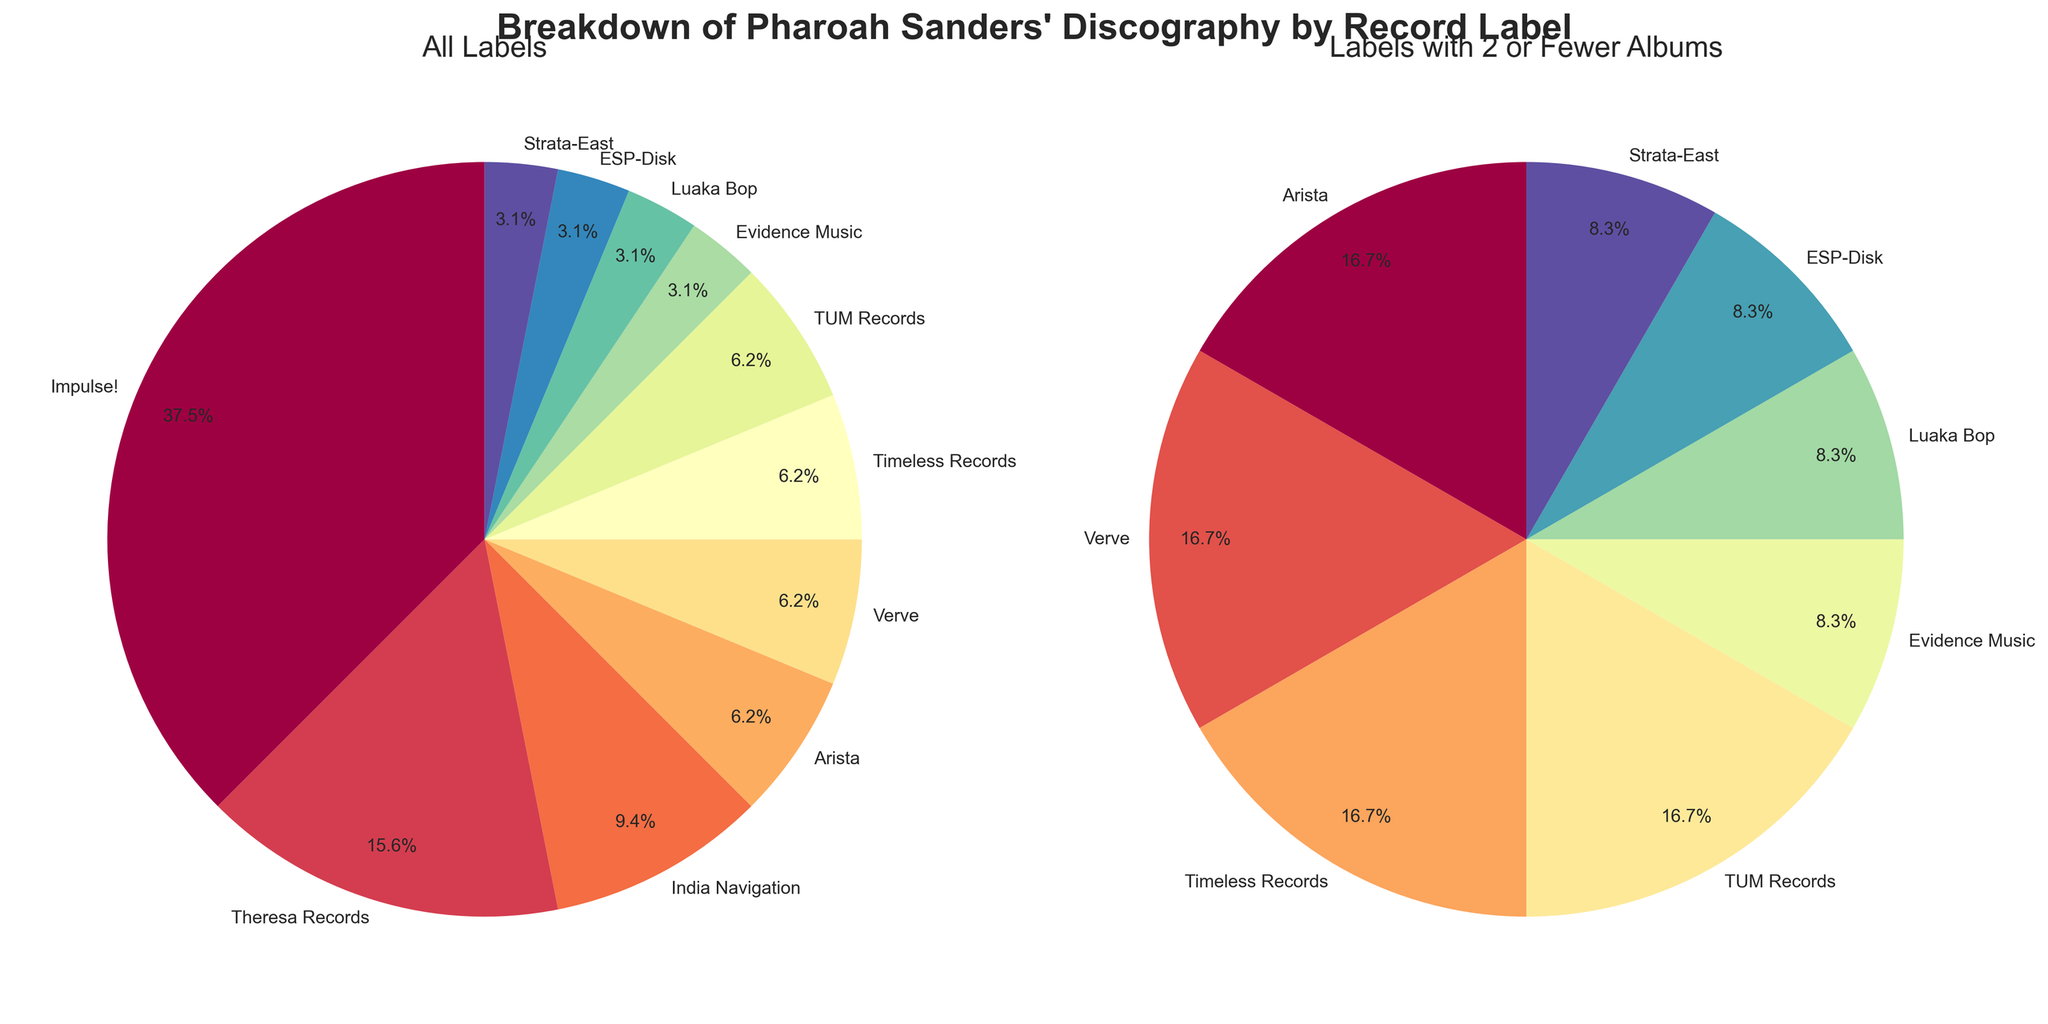What is the title of the figure? The title of the figure is displayed prominently at the top and reads "Breakdown of Pharoah Sanders' Discography by Record Label."
Answer: Breakdown of Pharoah Sanders' Discography by Record Label Which record label has the highest number of albums by Pharoah Sanders? The largest section in the main pie chart corresponds to the label with the highest number of albums. Impulse! has the largest section with 12 albums.
Answer: Impulse! How many record labels feature 2 or fewer albums by Pharoah Sanders? In the second pie chart titled "Labels with 2 or Fewer Albums," we can count the number of segments. There are 7 labels (Theresa Records, Verve, Timeless Records, TUM Records, Evidence Music, Luaka Bop, ESP-Disk, Strata-East) each with 2 or fewer albums.
Answer: 7 Which record labels have exactly 2 albums by Pharoah Sanders? In the second pie chart, segments labeled with 2 albums can be identified. The labels are Verve, Timeless Records, TUM Records, and Arista.
Answer: Verve, Timeless Records, TUM Records, Arista What percentage of the total albums are under Impulse!? Referring to the main pie chart, the segment for Impulse! shows an autopct label. Impulse! is marked with '63.2%' indicating it holds this percentage of total albums.
Answer: 63.2% Comparing India Navigation and Theresa Records, which label has more albums? Using the segments in the main pie chart, identify the two labels and compare their sizes. Theresa Records has 5 albums, which is more than India Navigation's 3 albums.
Answer: Theresa Records How many albums are produced by labels other than Impulse!? Sum the albums from all labels except Impulse!. Theresa Records has 5, India Navigation has 3, Arista has 2, Verve has 2, Timeless Records has 2, TUM Records has 2, Evidence Music has 1, Luaka Bop has 1, ESP-Disk has 1, and Strata-East has 1. 5 + 3 + 2 + 2 + 2 + 2 + 1 + 1 + 1 + 1 = 20 albums.
Answer: 20 What is the combined percentage of albums released under labels with 2 or fewer albums? Calculate the total number of albums for labels with 2 or fewer albums and divide by the total number of albums, then multiply by 100. (2 + 2 + 2 + 1 + 1 + 1 + 1)/32 = 10/32 = 0.3125 ≈ 31.3%.
Answer: 31.3% In the second pie chart, which label has the same number of albums as Verve? In the second pie chart, Verve has 2 albums. The other labels with 2 albums are Timeless Records, TUM Records, and Arista. Since Arista is also listed, it must be in both charts.
Answer: Arista 